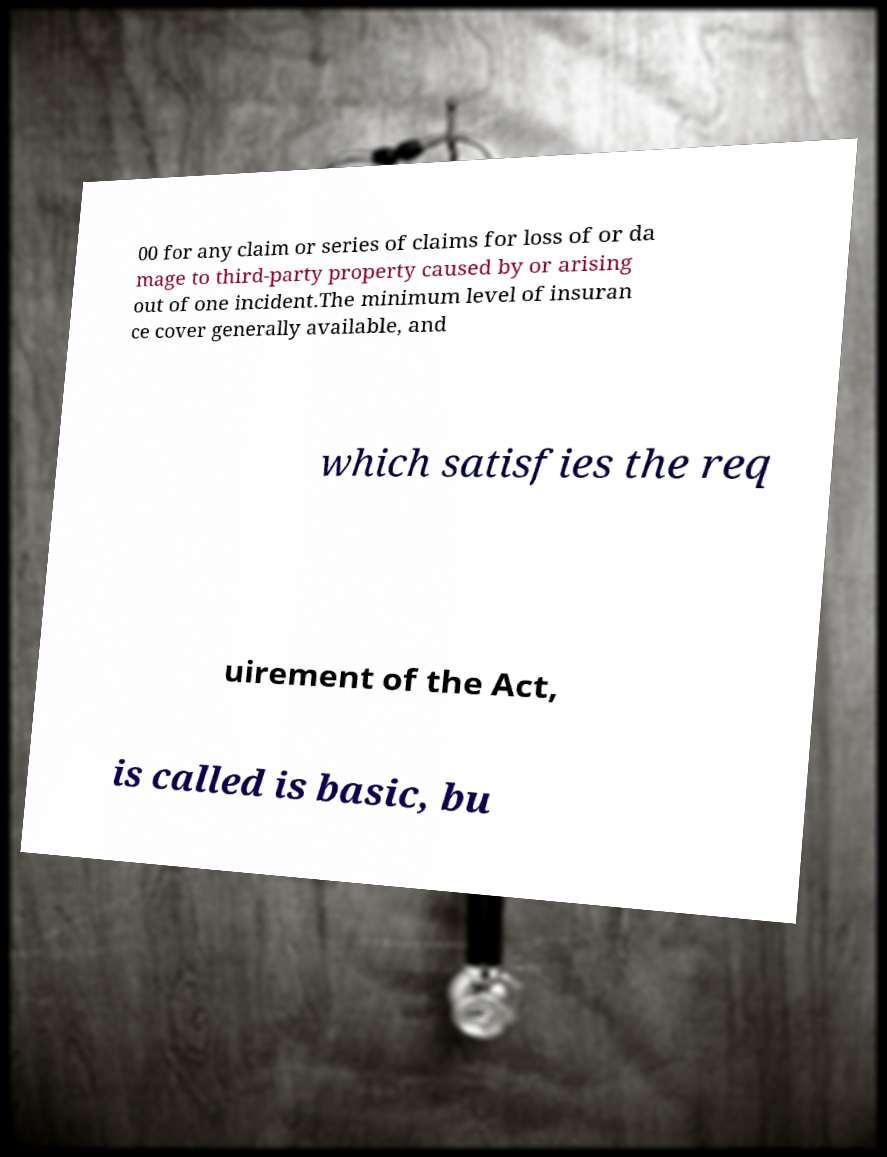Can you accurately transcribe the text from the provided image for me? 00 for any claim or series of claims for loss of or da mage to third-party property caused by or arising out of one incident.The minimum level of insuran ce cover generally available, and which satisfies the req uirement of the Act, is called is basic, bu 